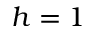Convert formula to latex. <formula><loc_0><loc_0><loc_500><loc_500>h = 1</formula> 